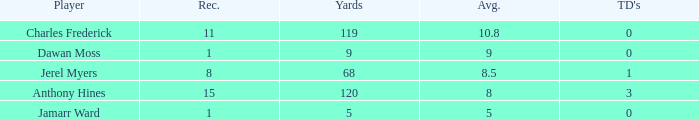What is the total Avg when TDs are 0 and Dawan Moss is a player? 0.0. 